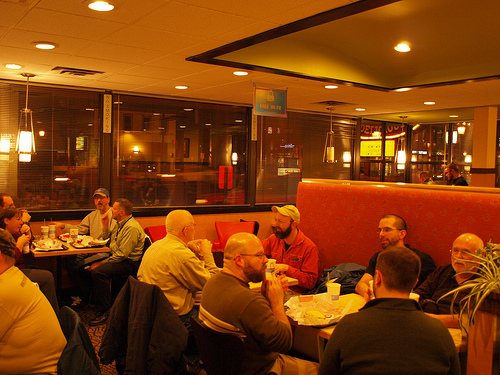<image>
Can you confirm if the window is behind the table? Yes. From this viewpoint, the window is positioned behind the table, with the table partially or fully occluding the window. 